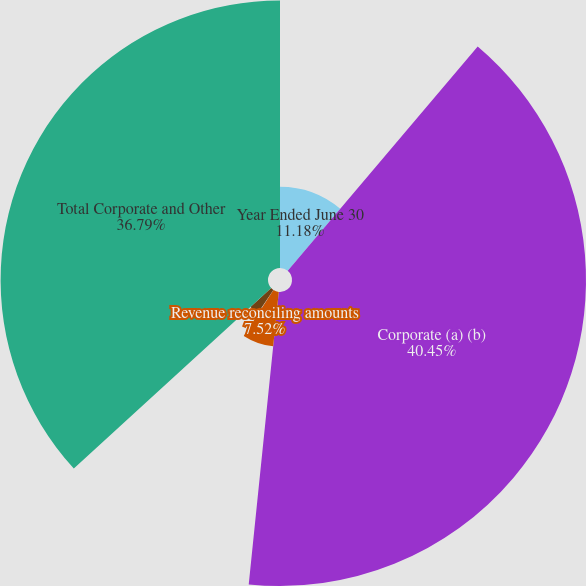<chart> <loc_0><loc_0><loc_500><loc_500><pie_chart><fcel>Year Ended June 30<fcel>Corporate (a) (b)<fcel>Revenue reconciling amounts<fcel>Cost of revenue reconciling<fcel>Operating expenses reconciling<fcel>Total Corporate and Other<nl><fcel>11.18%<fcel>40.45%<fcel>7.52%<fcel>0.2%<fcel>3.86%<fcel>36.79%<nl></chart> 